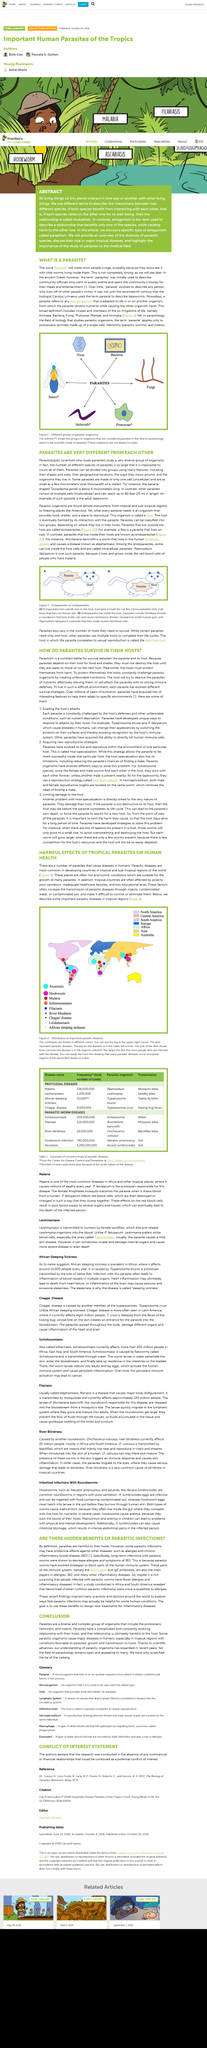Outline some significant characteristics in this image. Carolus Linnaeus, a renowned biologist, is credited with coining the term "parasite" to describe tapeworms. Parasitic diseases are most prevalent in developing countries located in tropical and sub-tropical regions of the world, where they pose a significant public health threat. Ectoparasites are parasites that live outside of their host, which is called a parasite that lives outside of the host. Parasitologists are scientists who specialize in the study of parasites. The goal of scientists who are exploring ways that parasitic infections can be helpful is to design new treatments for inflammatory diseases. 